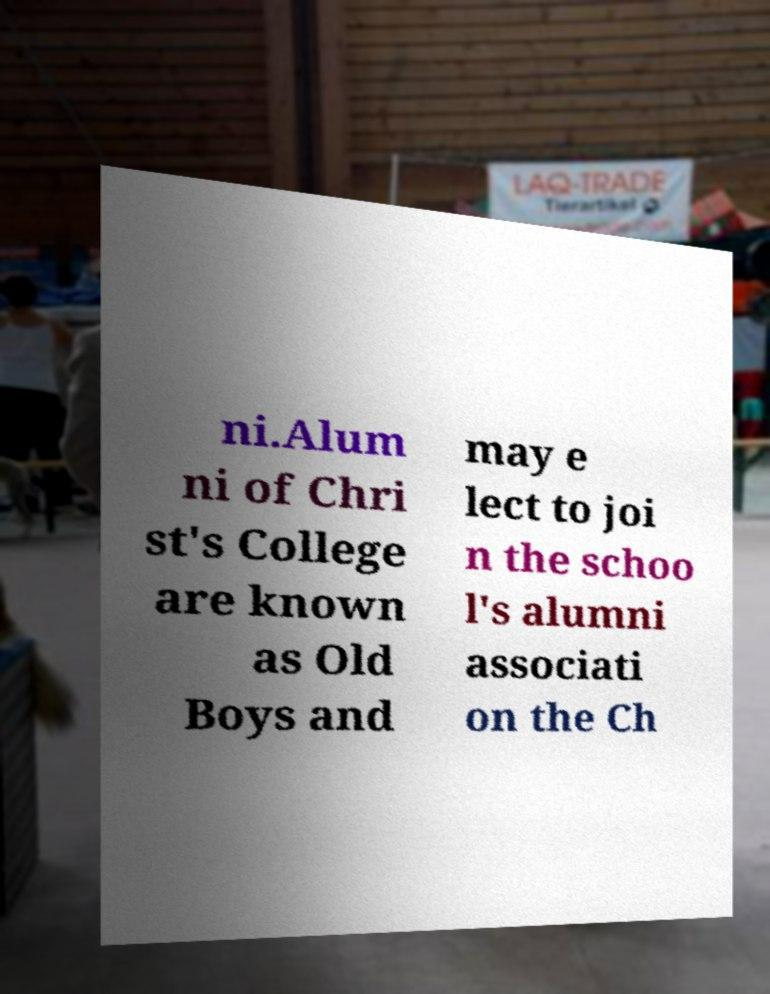Could you extract and type out the text from this image? ni.Alum ni of Chri st's College are known as Old Boys and may e lect to joi n the schoo l's alumni associati on the Ch 